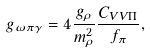<formula> <loc_0><loc_0><loc_500><loc_500>g _ { \omega \pi \gamma } = 4 \frac { g _ { \rho } } { m _ { \rho } ^ { 2 } } \frac { C _ { V V \Pi } } { f _ { \pi } } ,</formula> 